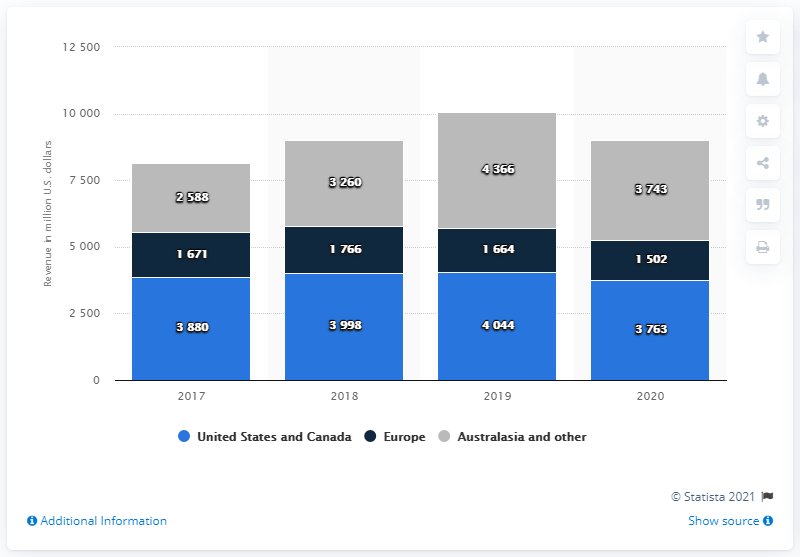Outline some significant characteristics in this image. In 2020, News Corp. generated a significant portion of its revenue from Europe, with the region contributing to approximately 1502 of its overall revenue. In 2020, approximately 37.63% of News Corp.'s revenue was generated from customers in the United States and Canada. 